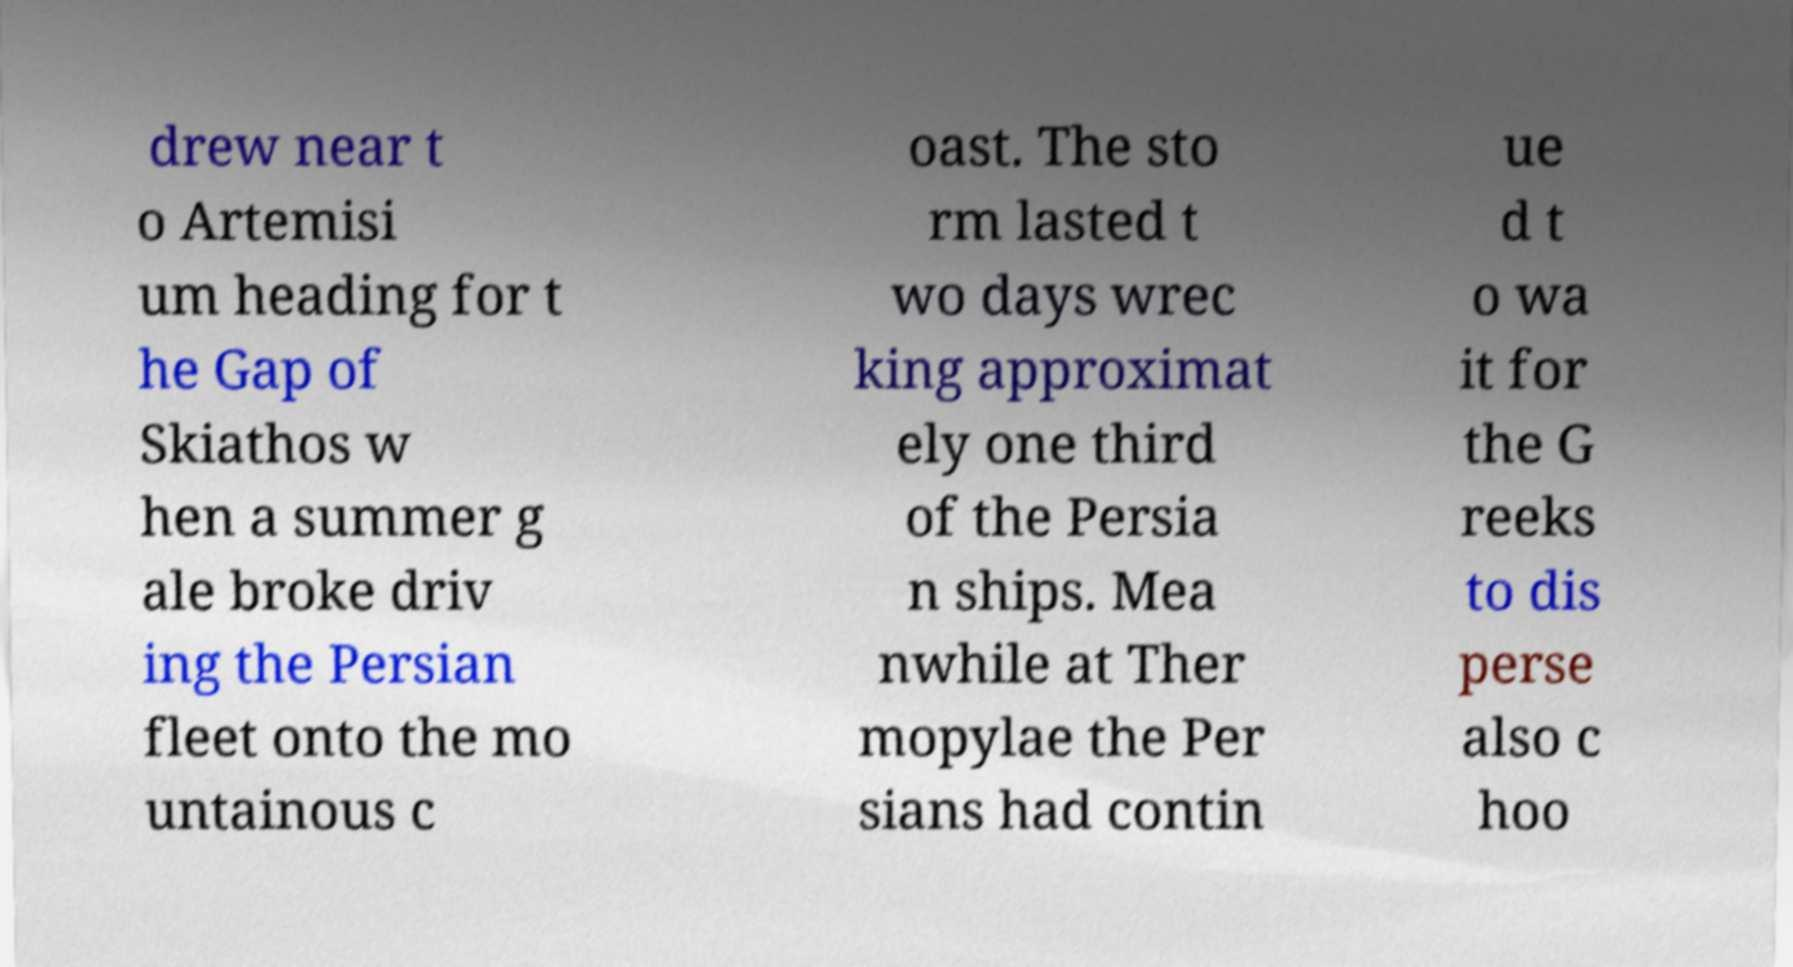Can you accurately transcribe the text from the provided image for me? drew near t o Artemisi um heading for t he Gap of Skiathos w hen a summer g ale broke driv ing the Persian fleet onto the mo untainous c oast. The sto rm lasted t wo days wrec king approximat ely one third of the Persia n ships. Mea nwhile at Ther mopylae the Per sians had contin ue d t o wa it for the G reeks to dis perse also c hoo 